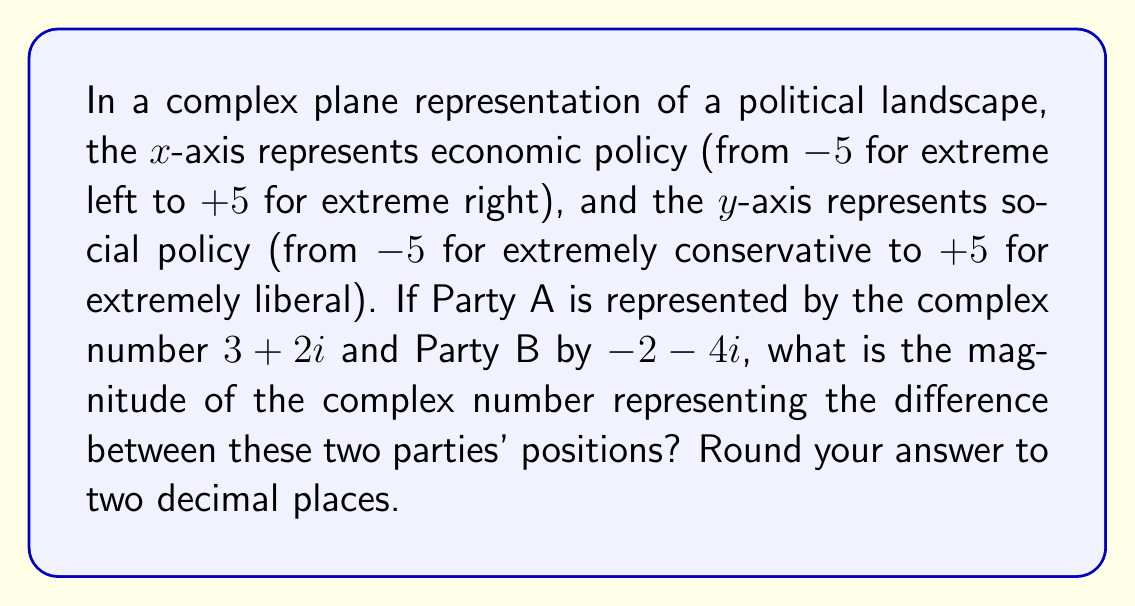Give your solution to this math problem. To solve this problem, we'll follow these steps:

1) The difference between the two parties' positions is represented by subtracting the complex numbers:
   $$(3+2i) - (-2-4i) = 3+2i+2+4i = 5+6i$$

2) To find the magnitude of this difference, we use the formula for the absolute value of a complex number:
   For a complex number $a+bi$, the magnitude is given by $\sqrt{a^2 + b^2}$

3) In this case, we have $5+6i$, so:
   $a = 5$ and $b = 6$

4) Applying the formula:
   $$\sqrt{5^2 + 6^2} = \sqrt{25 + 36} = \sqrt{61}$$

5) Calculate the square root:
   $\sqrt{61} \approx 7.8102$

6) Rounding to two decimal places:
   $7.81$

This magnitude represents the Euclidean distance between the two parties in this two-dimensional political space.
Answer: $7.81$ 